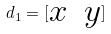Convert formula to latex. <formula><loc_0><loc_0><loc_500><loc_500>d _ { 1 } = [ \begin{matrix} x & y \\ \end{matrix} ]</formula> 